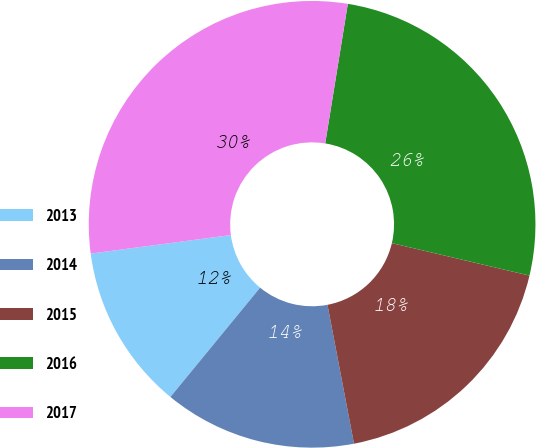<chart> <loc_0><loc_0><loc_500><loc_500><pie_chart><fcel>2013<fcel>2014<fcel>2015<fcel>2016<fcel>2017<nl><fcel>11.97%<fcel>13.94%<fcel>18.31%<fcel>26.13%<fcel>29.65%<nl></chart> 